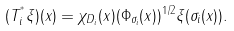Convert formula to latex. <formula><loc_0><loc_0><loc_500><loc_500>( T _ { i } ^ { ^ { * } } \xi ) ( x ) = \chi _ { D _ { i } } ( x ) ( \Phi _ { \sigma _ { i } } ( x ) ) ^ { 1 / 2 } \xi ( \sigma _ { i } ( x ) ) .</formula> 